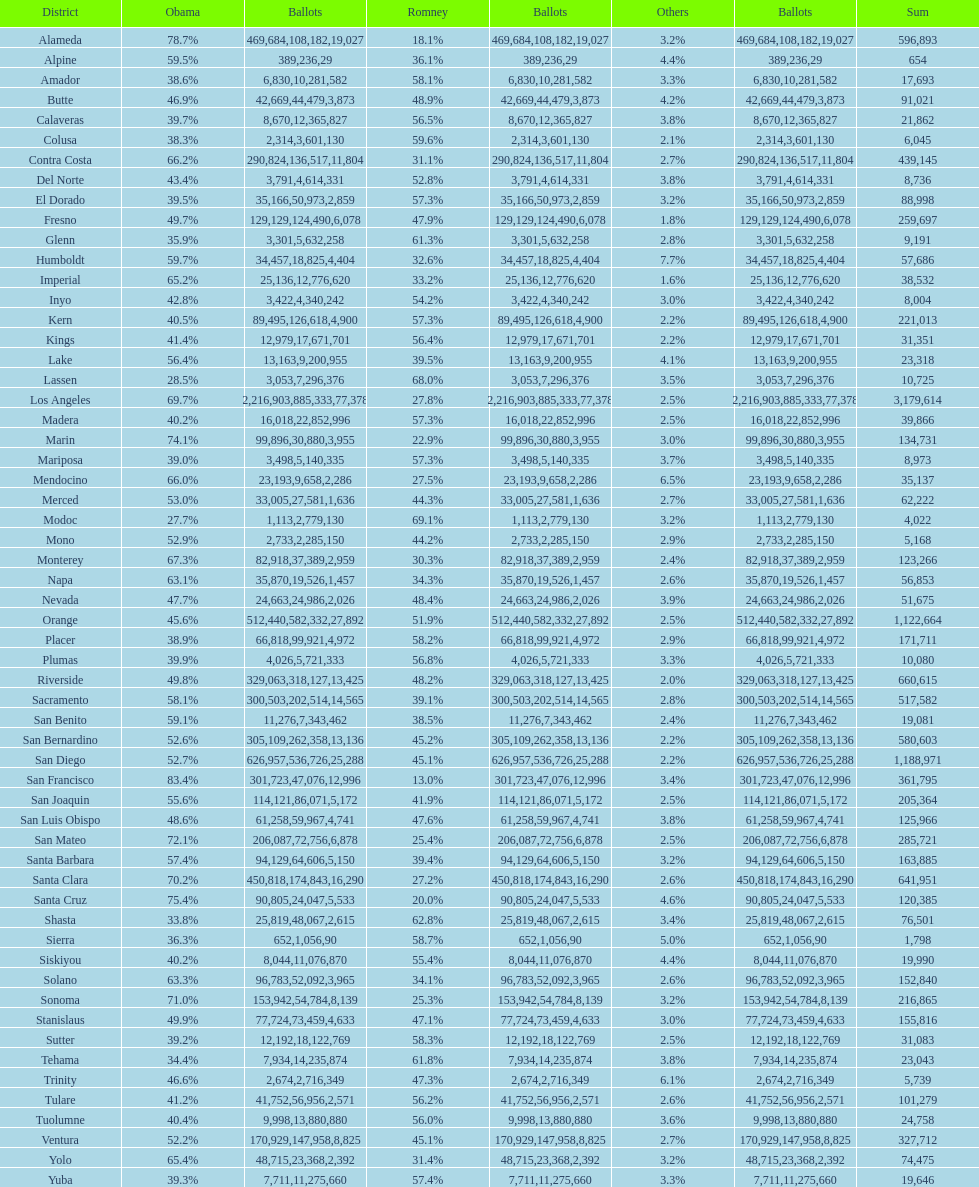Which county had the lower percentage votes for obama: amador, humboldt, or lake? Amador. 